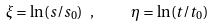Convert formula to latex. <formula><loc_0><loc_0><loc_500><loc_500>\xi = \ln ( s / s _ { 0 } ) \ , \quad \ \eta = \ln ( t / t _ { 0 } )</formula> 